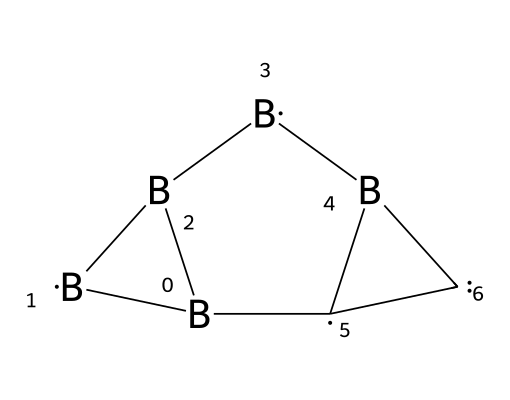How many boron atoms are present in this structure? The SMILES representation indicates that there are four occurrences of the element 'B', which represents the boron atoms in the compound.
Answer: four How many carbon atoms are present in this structure? The SMILES representation has two occurrences of the element 'C', which indicates the presence of two carbon atoms in the structure.
Answer: two What type of bonding is primarily present in carboranes? Carboranes feature a unique bonding type that consists of covalent bonds formed between boron and carbon atoms, resulting in a stable polyhedral structure.
Answer: covalent What is the overall shape of this carborane structure? The bonding arrangement leads to a three-dimensional polyhedral shape, specifically resembling that of a dodecahedron due to the interconnected atoms.
Answer: polyhedral What is the coordination number of the boron atoms in this structure? Each boron atom is typically coordinated to three other atoms due to its tetravalent nature, resulting in a coordination number of three.
Answer: three What distinguishes carboranes from simple boranes? Carboranes include carbon atoms within their structure, which contributes to their stability and unique properties, unlike simple boranes that only consist of boron atoms.
Answer: carbon inclusion 